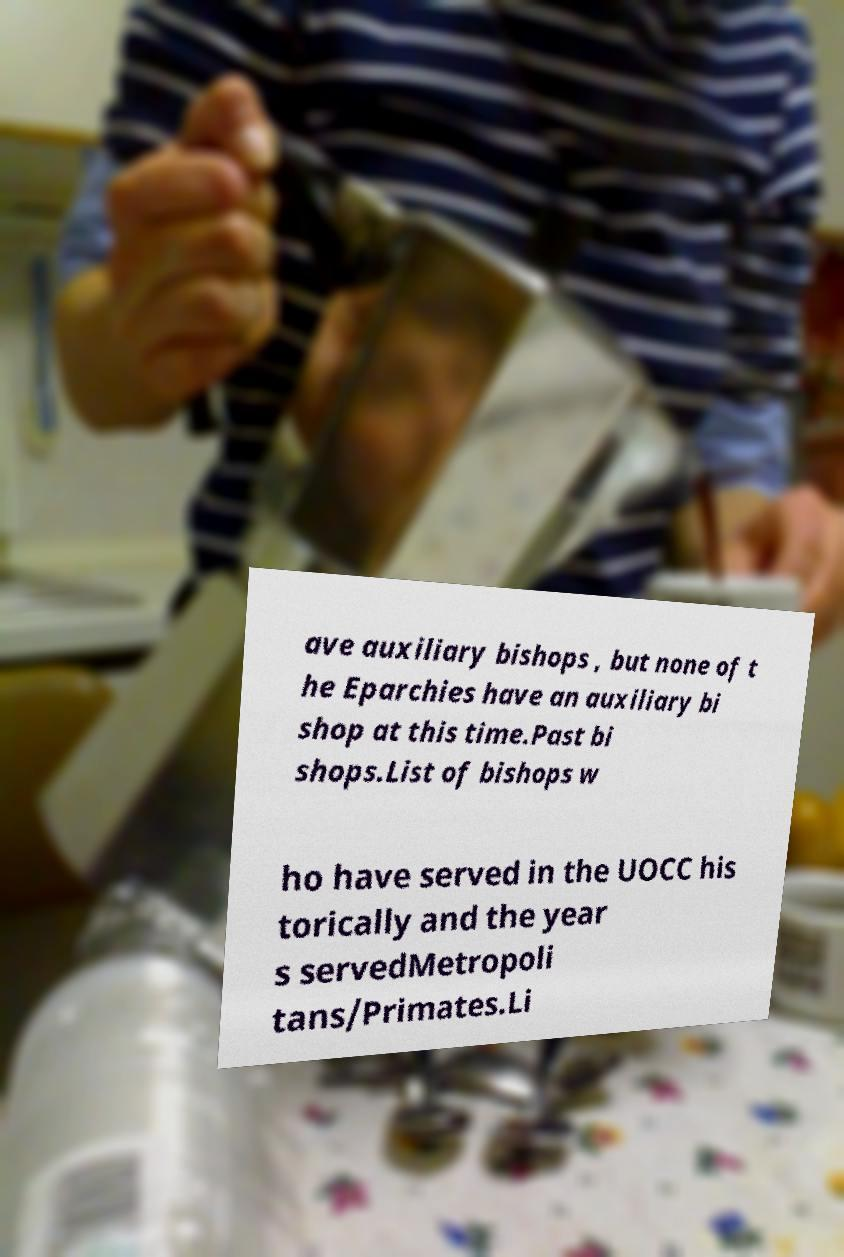I need the written content from this picture converted into text. Can you do that? ave auxiliary bishops , but none of t he Eparchies have an auxiliary bi shop at this time.Past bi shops.List of bishops w ho have served in the UOCC his torically and the year s servedMetropoli tans/Primates.Li 